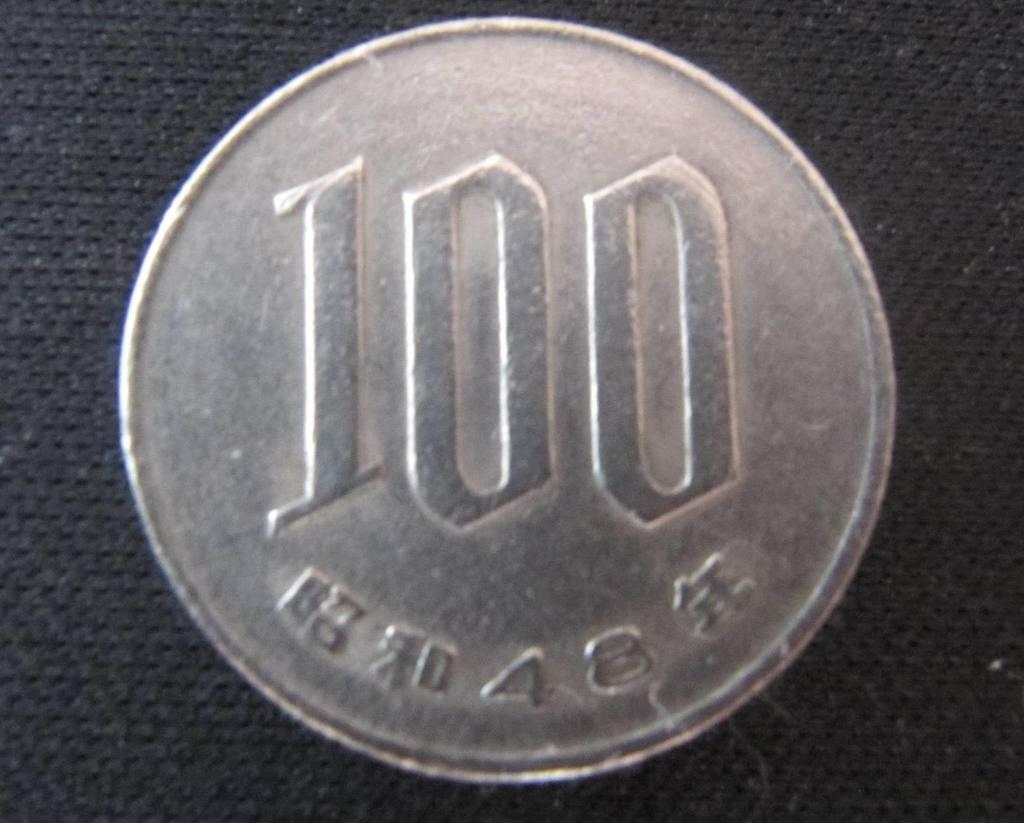<image>
Write a terse but informative summary of the picture. a silver coin that reads 100 and placed on the counter 